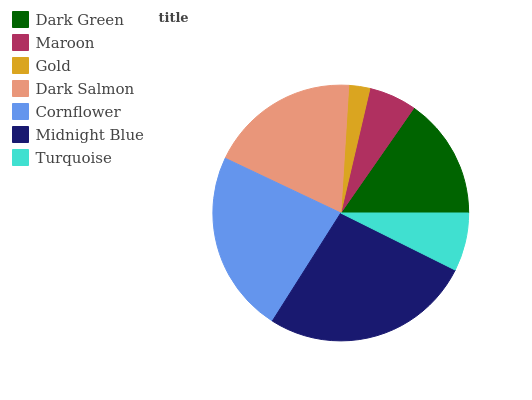Is Gold the minimum?
Answer yes or no. Yes. Is Midnight Blue the maximum?
Answer yes or no. Yes. Is Maroon the minimum?
Answer yes or no. No. Is Maroon the maximum?
Answer yes or no. No. Is Dark Green greater than Maroon?
Answer yes or no. Yes. Is Maroon less than Dark Green?
Answer yes or no. Yes. Is Maroon greater than Dark Green?
Answer yes or no. No. Is Dark Green less than Maroon?
Answer yes or no. No. Is Dark Green the high median?
Answer yes or no. Yes. Is Dark Green the low median?
Answer yes or no. Yes. Is Cornflower the high median?
Answer yes or no. No. Is Turquoise the low median?
Answer yes or no. No. 